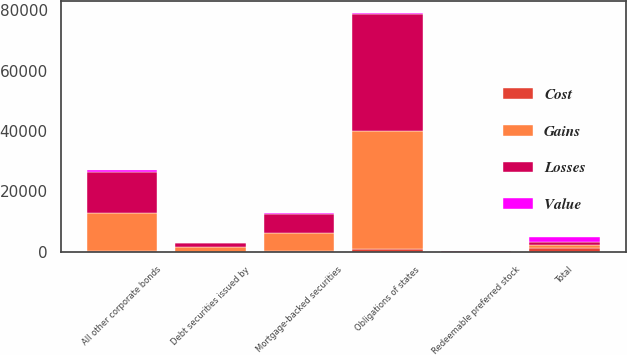<chart> <loc_0><loc_0><loc_500><loc_500><stacked_bar_chart><ecel><fcel>Obligations of states<fcel>Debt securities issued by<fcel>Mortgage-backed securities<fcel>All other corporate bonds<fcel>Redeemable preferred stock<fcel>Total<nl><fcel>Losses<fcel>38598<fcel>1453<fcel>6266<fcel>13498<fcel>73<fcel>901<nl><fcel>Cost<fcel>920<fcel>67<fcel>157<fcel>121<fcel>1<fcel>1426<nl><fcel>Value<fcel>456<fcel>1<fcel>364<fcel>882<fcel>17<fcel>1720<nl><fcel>Gains<fcel>39062<fcel>1519<fcel>6059<fcel>12737<fcel>57<fcel>901<nl></chart> 